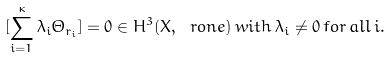Convert formula to latex. <formula><loc_0><loc_0><loc_500><loc_500>[ \sum _ { i = 1 } ^ { \kappa } \lambda _ { i } \Theta _ { r _ { i } } ] = 0 \in H ^ { 3 } ( X , \ r o n e ) \, w i t h \, \lambda _ { i } \not = 0 \, f o r \, a l l \, i .</formula> 